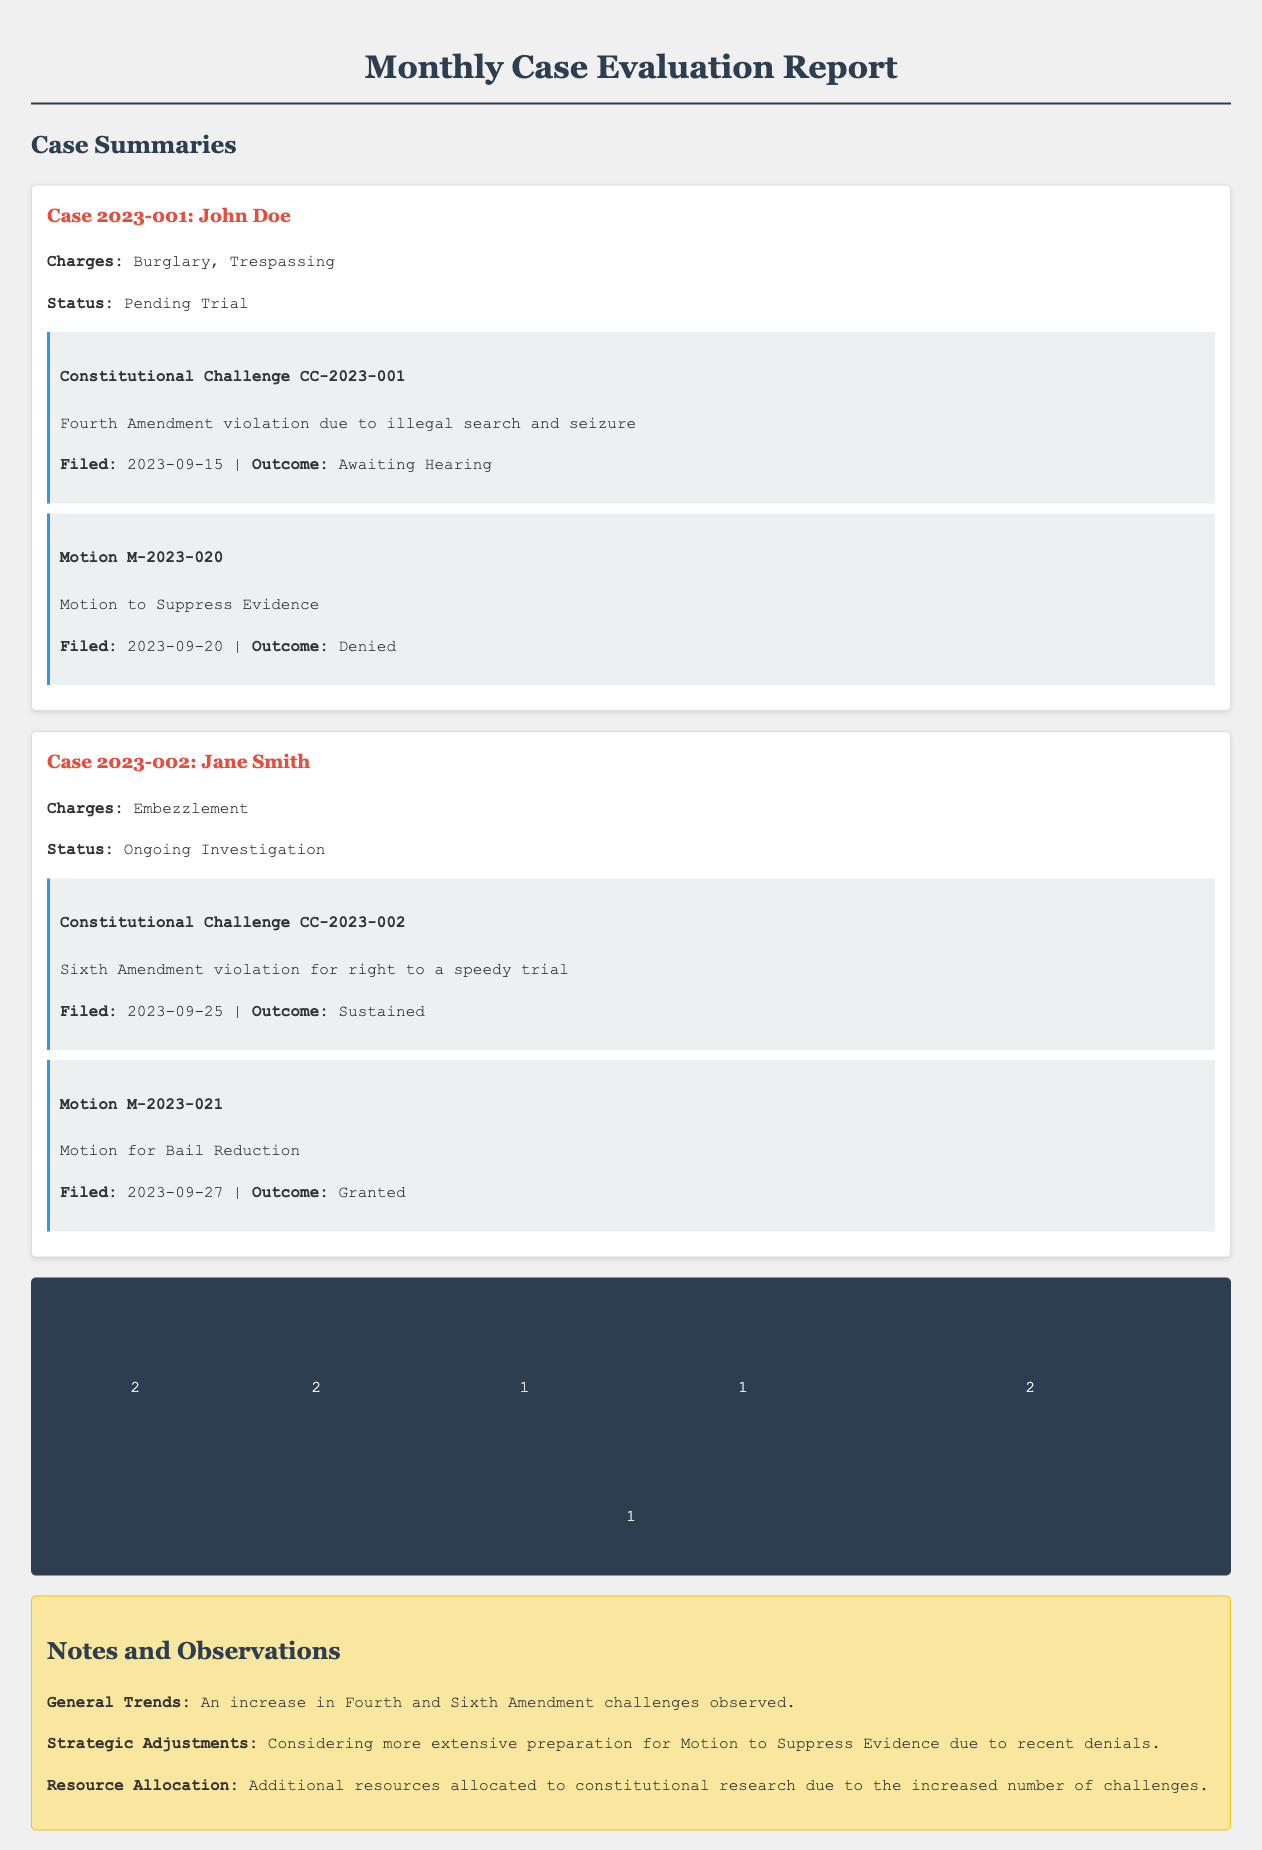What are the charges against John Doe? The document lists the charges against John Doe as Burglary and Trespassing.
Answer: Burglary, Trespassing What is the status of Case 2023-002? The status of Case 2023-002, involving Jane Smith, is recorded as Ongoing Investigation.
Answer: Ongoing Investigation When was the Motion for Bail Reduction filed? The date the Motion for Bail Reduction was filed is specified as September 27, 2023.
Answer: 2023-09-27 How many total cases are there in the report? The total number of cases mentioned in the report is stated directly in the statistics section.
Answer: 2 What was the outcome of the Fourth Amendment challenge for John Doe? The outcome of the Fourth Amendment challenge for John Doe is indicated as Awaiting Hearing in the document.
Answer: Awaiting Hearing Which constitutional amendment is referenced in Jane Smith's challenge? The challenge related to Jane Smith references the Sixth Amendment, which concerns the right to a speedy trial.
Answer: Sixth Amendment How many motions were granted in total? The total number of motions granted is shown in the statistics and is one motion.
Answer: 1 What trends are noted in the observations section? The general trends noted in the observations section include an increase in Fourth and Sixth Amendment challenges.
Answer: Increase in Fourth and Sixth Amendment challenges What was the outcome of the motion to suppress evidence for John Doe? The document specifies that the outcome of the motion to suppress evidence for John Doe was Denied.
Answer: Denied 